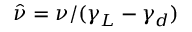<formula> <loc_0><loc_0><loc_500><loc_500>\hat { \nu } = \nu / ( \gamma _ { L } - \gamma _ { d } )</formula> 